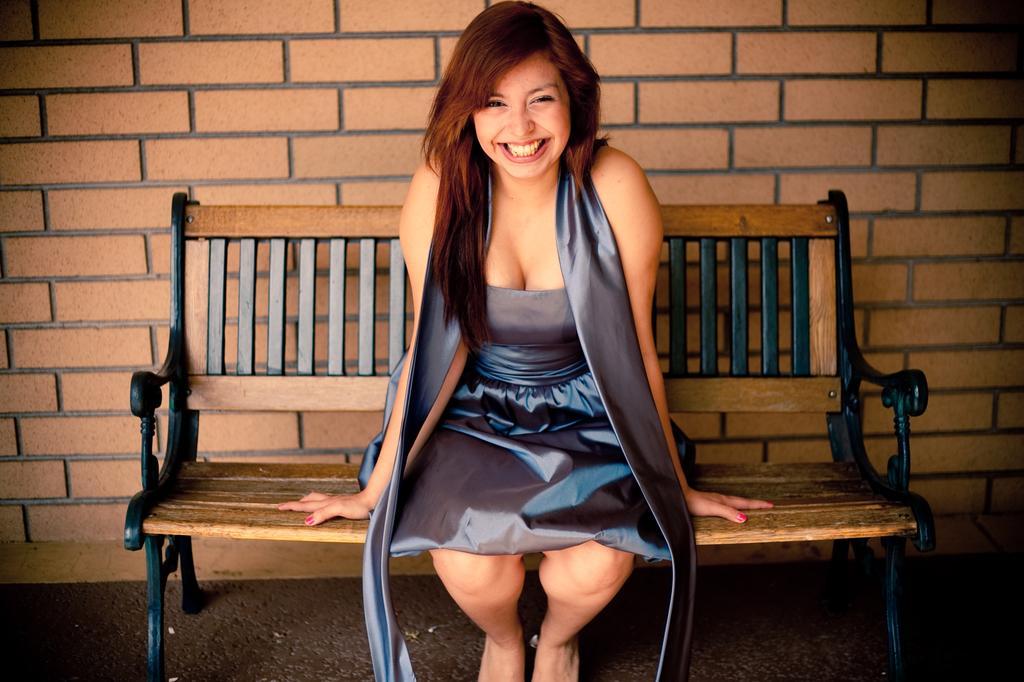How would you summarize this image in a sentence or two? As we can see in the image there is a brick wall and a woman sitting on bench. 